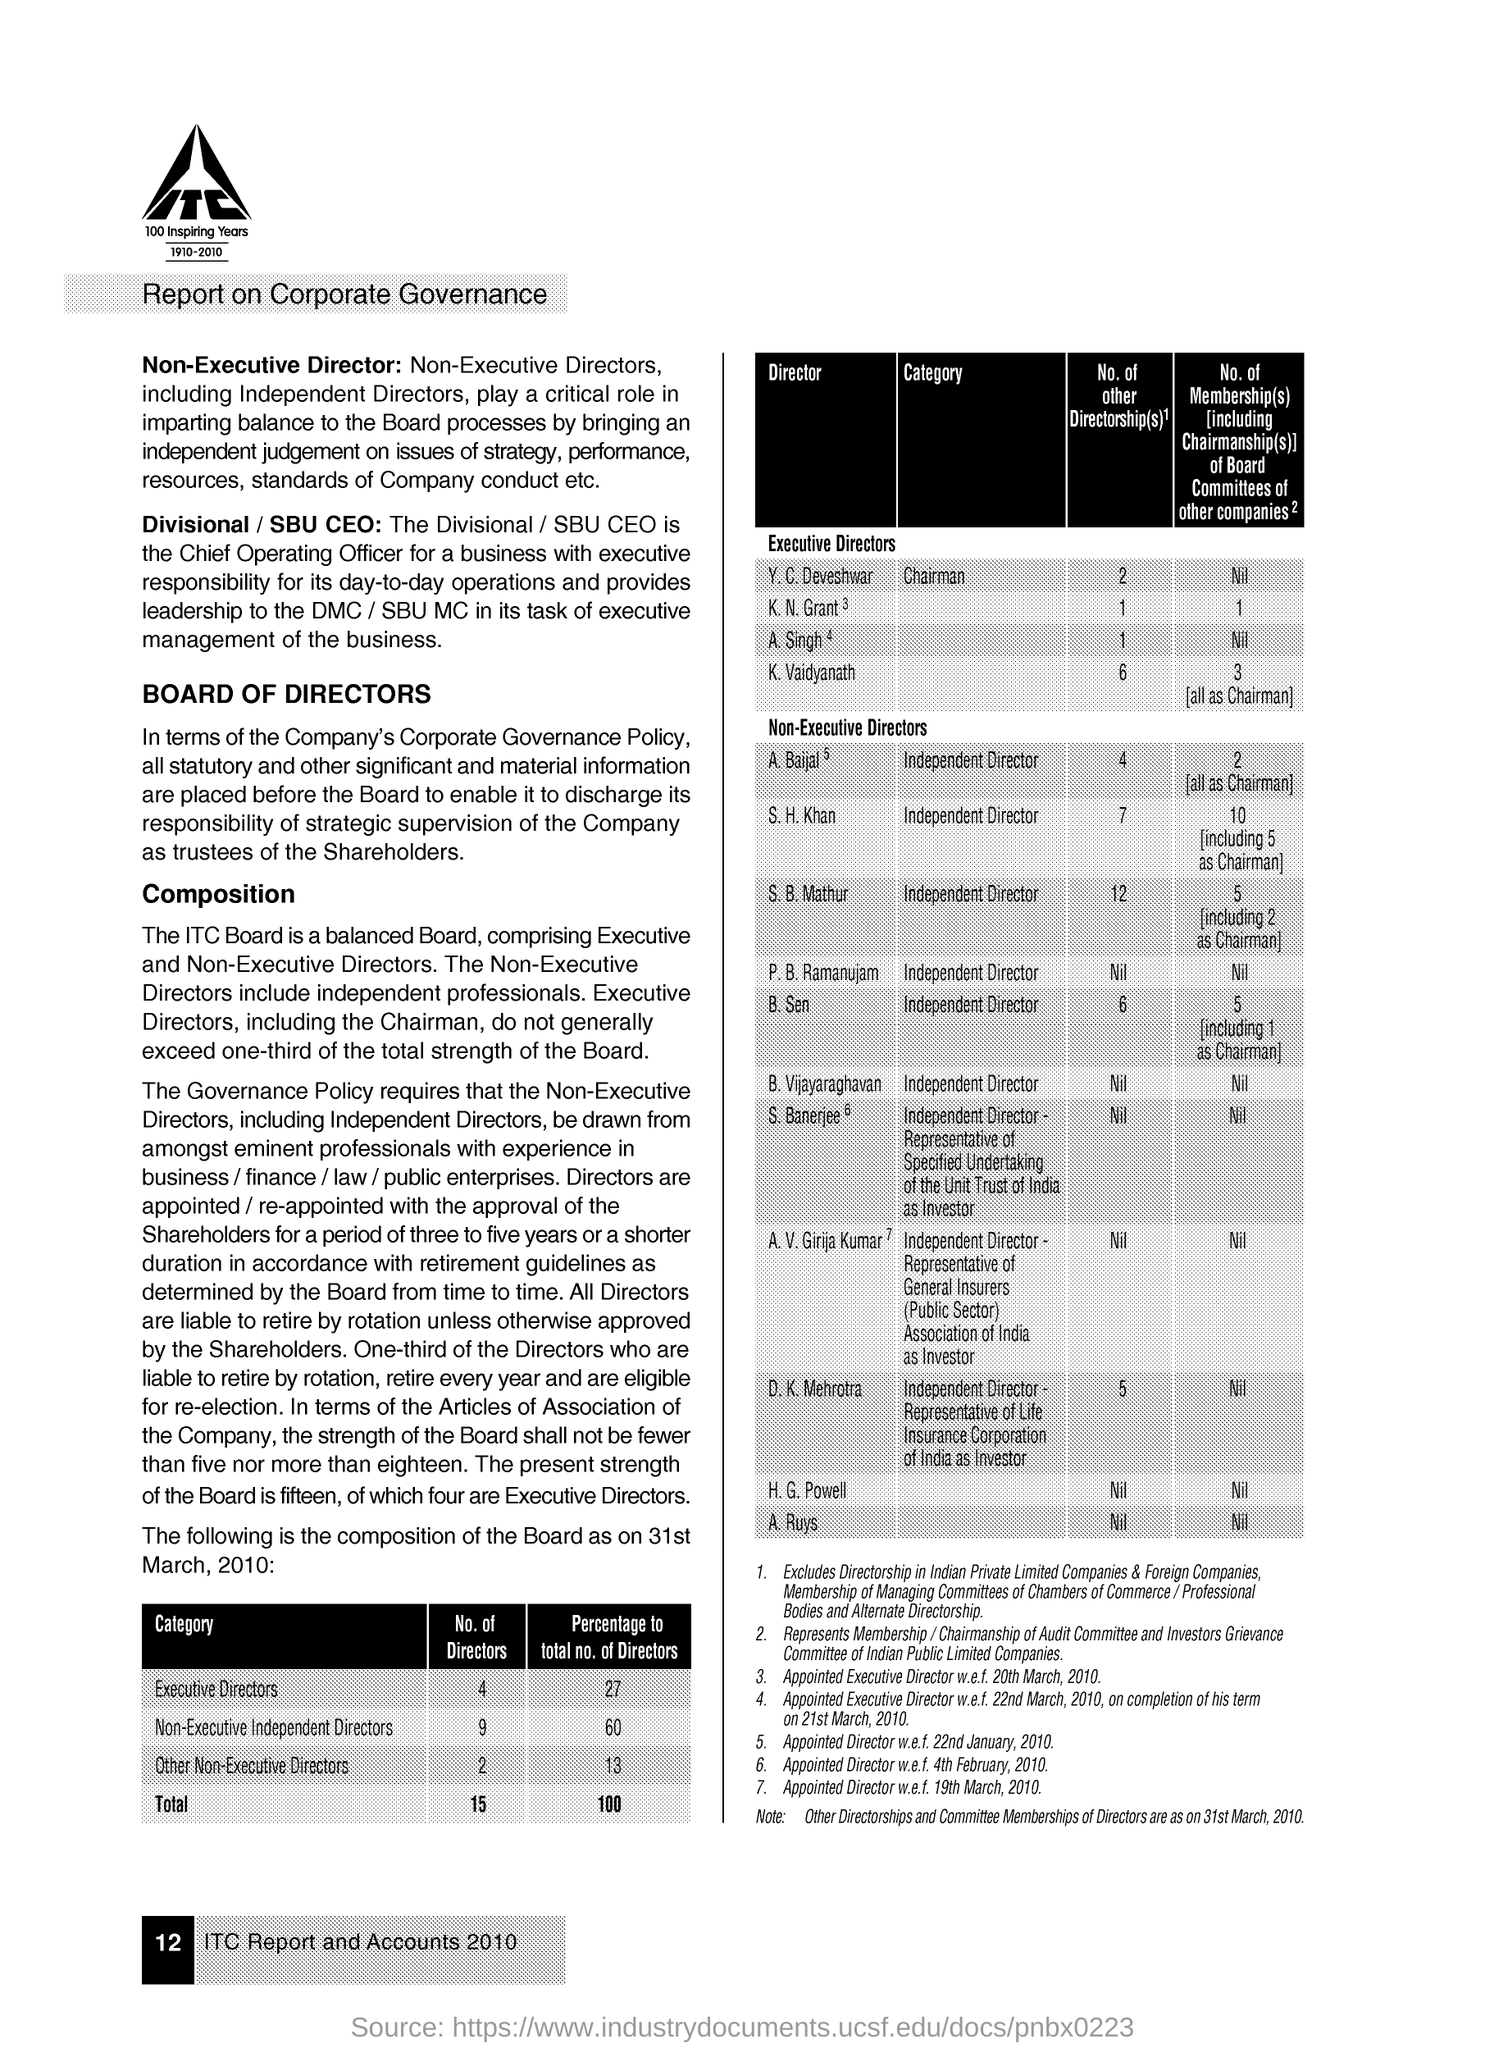Identify some key points in this picture. There are four Executive Directors in the category. 